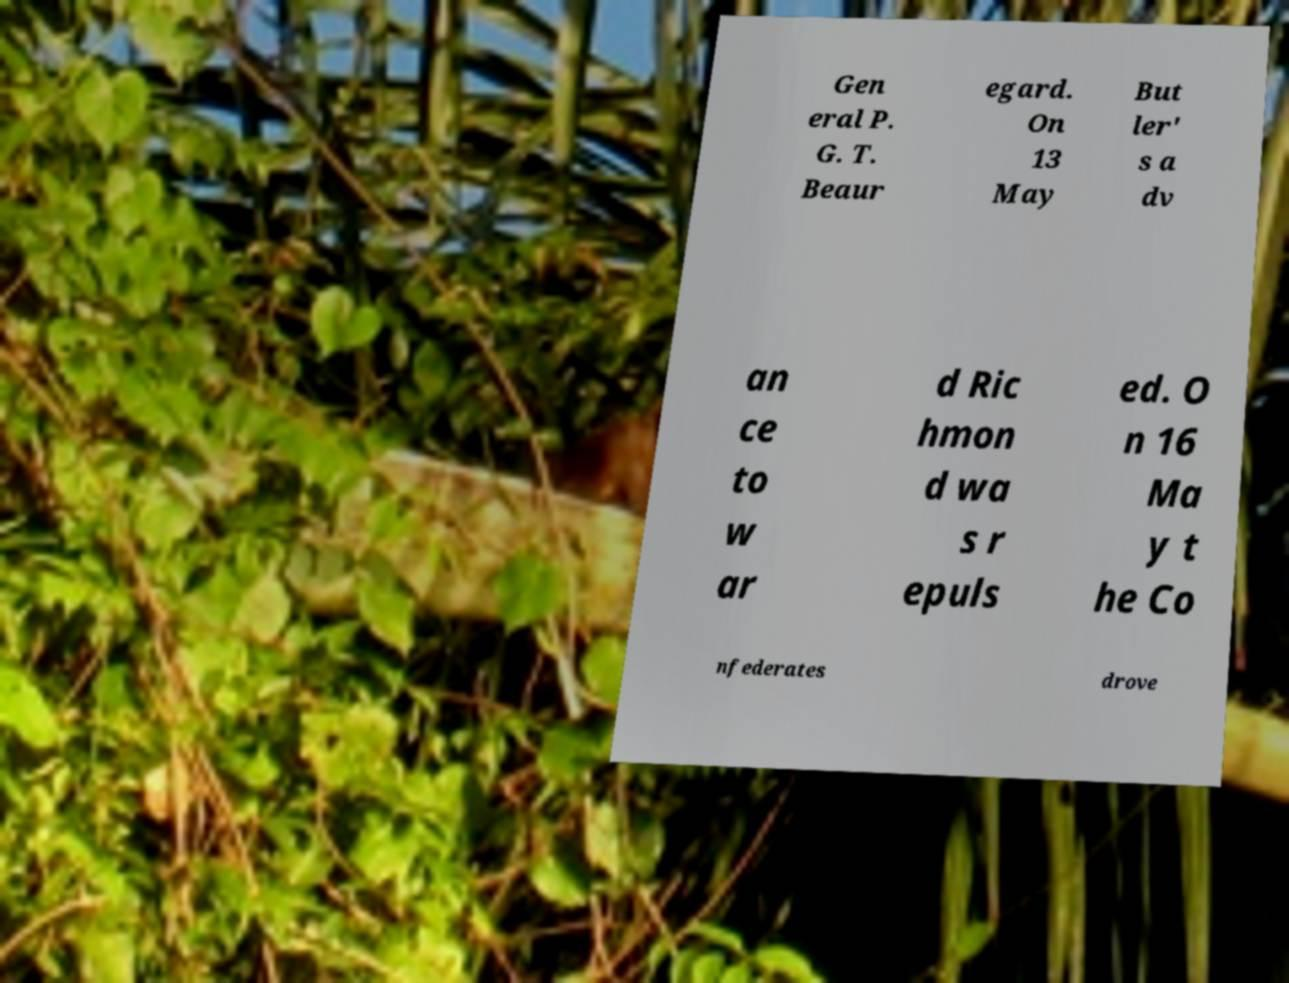Please identify and transcribe the text found in this image. Gen eral P. G. T. Beaur egard. On 13 May But ler' s a dv an ce to w ar d Ric hmon d wa s r epuls ed. O n 16 Ma y t he Co nfederates drove 